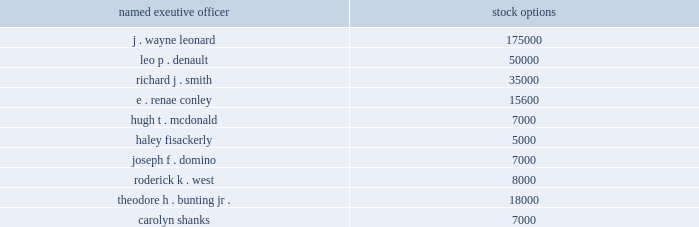For purposes of determining entergy corporation's relative performance for the 2006-2008 period , the committee used the philadelphia utility index as the peer group .
Based on market data and the recommendation of management , the committee compared entergy corporation's total shareholder return against the total shareholder return of the companies that comprised the philadelphia utility index .
Based on a comparison of entergy corporation's performance relative to the philadelphia utility index as described above , the committee concluded that entergy corporation had exceeded the performance targets for the 2006-2008 performance cycle with entergy finishing in the first quartile which resulted in a payment of 250% ( 250 % ) of target ( the maximum amount payable ) .
Each performance unit was then automatically converted into cash at the rate of $ 83.13 per unit , the closing price of entergy corporation common stock on the last trading day of the performance cycle ( december 31 , 2008 ) , plus dividend equivalents accrued over the three-year performance cycle .
See the 2008 option exercises and stock vested table for the amount paid to each of the named executive officers for the 2006-2008 performance unit cycle .
Stock options the personnel committee and in the case of the named executive officers ( other than mr .
Leonard , mr .
Denault and mr .
Smith ) , entergy's chief executive officer and the named executive officer's supervisor consider several factors in determining the amount of stock options it will grant under entergy's equity ownership plans to the named executive officers , including : individual performance ; prevailing market practice in stock option grants ; the targeted long-term value created by the use of stock options ; the number of participants eligible for stock options , and the resulting "burn rate" ( i.e. , the number of stock options authorized divided by the total number of shares outstanding ) to assess the potential dilutive effect ; and the committee's assessment of other elements of compensation provided to the named executive officer for stock option awards to the named executive officers ( other than mr .
Leonard ) , the committee's assessment of individual performance of each named executive officer done in consultation with entergy corporation's chief executive officer is the most important factor in determining the number of options awarded .
The table sets forth the number of stock options granted to each named executive officer in 2008 .
The exercise price for each option was $ 108.20 , which was the closing fair market value of entergy corporation common stock on the date of grant. .
The option grants awarded to the named executive officers ( other than mr .
Leonard and mr .
Lewis ) ranged in amount between 5000 and 50000 shares .
Mr .
Lewis did not receive any stock option awards in 2008 .
In the case of mr .
Leonard , who received 175000 stock options , the committee took special note of his performance as entergy corporation's chief executive officer .
Among other things , the committee noted that .
What is the total value of stock options for j . wayne leonard , in millions? 
Computations: ((175000 * 108.20) / 1000000)
Answer: 18.935. 